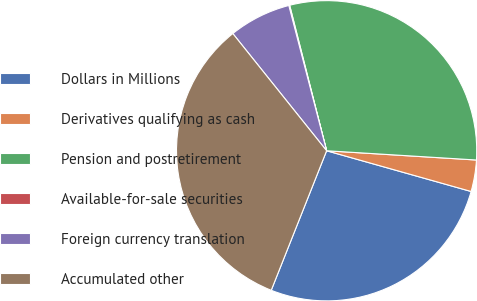Convert chart. <chart><loc_0><loc_0><loc_500><loc_500><pie_chart><fcel>Dollars in Millions<fcel>Derivatives qualifying as cash<fcel>Pension and postretirement<fcel>Available-for-sale securities<fcel>Foreign currency translation<fcel>Accumulated other<nl><fcel>26.64%<fcel>3.39%<fcel>29.94%<fcel>0.09%<fcel>6.69%<fcel>33.24%<nl></chart> 